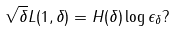Convert formula to latex. <formula><loc_0><loc_0><loc_500><loc_500>\sqrt { \delta } L ( 1 , \delta ) = H ( \delta ) \log \epsilon _ { \delta } ?</formula> 